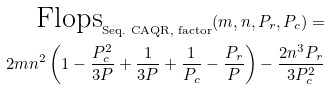Convert formula to latex. <formula><loc_0><loc_0><loc_500><loc_500>\text {Flops} _ { \text {Seq.\ CAQR, factor} } ( m , n , P _ { r } , P _ { c } ) = \\ 2 m n ^ { 2 } \left ( 1 - \frac { P _ { c } ^ { 2 } } { 3 P } + \frac { 1 } { 3 P } + \frac { 1 } { P _ { c } } - \frac { P _ { r } } { P } \right ) - \frac { 2 n ^ { 3 } P _ { r } } { 3 P _ { c } ^ { 2 } }</formula> 